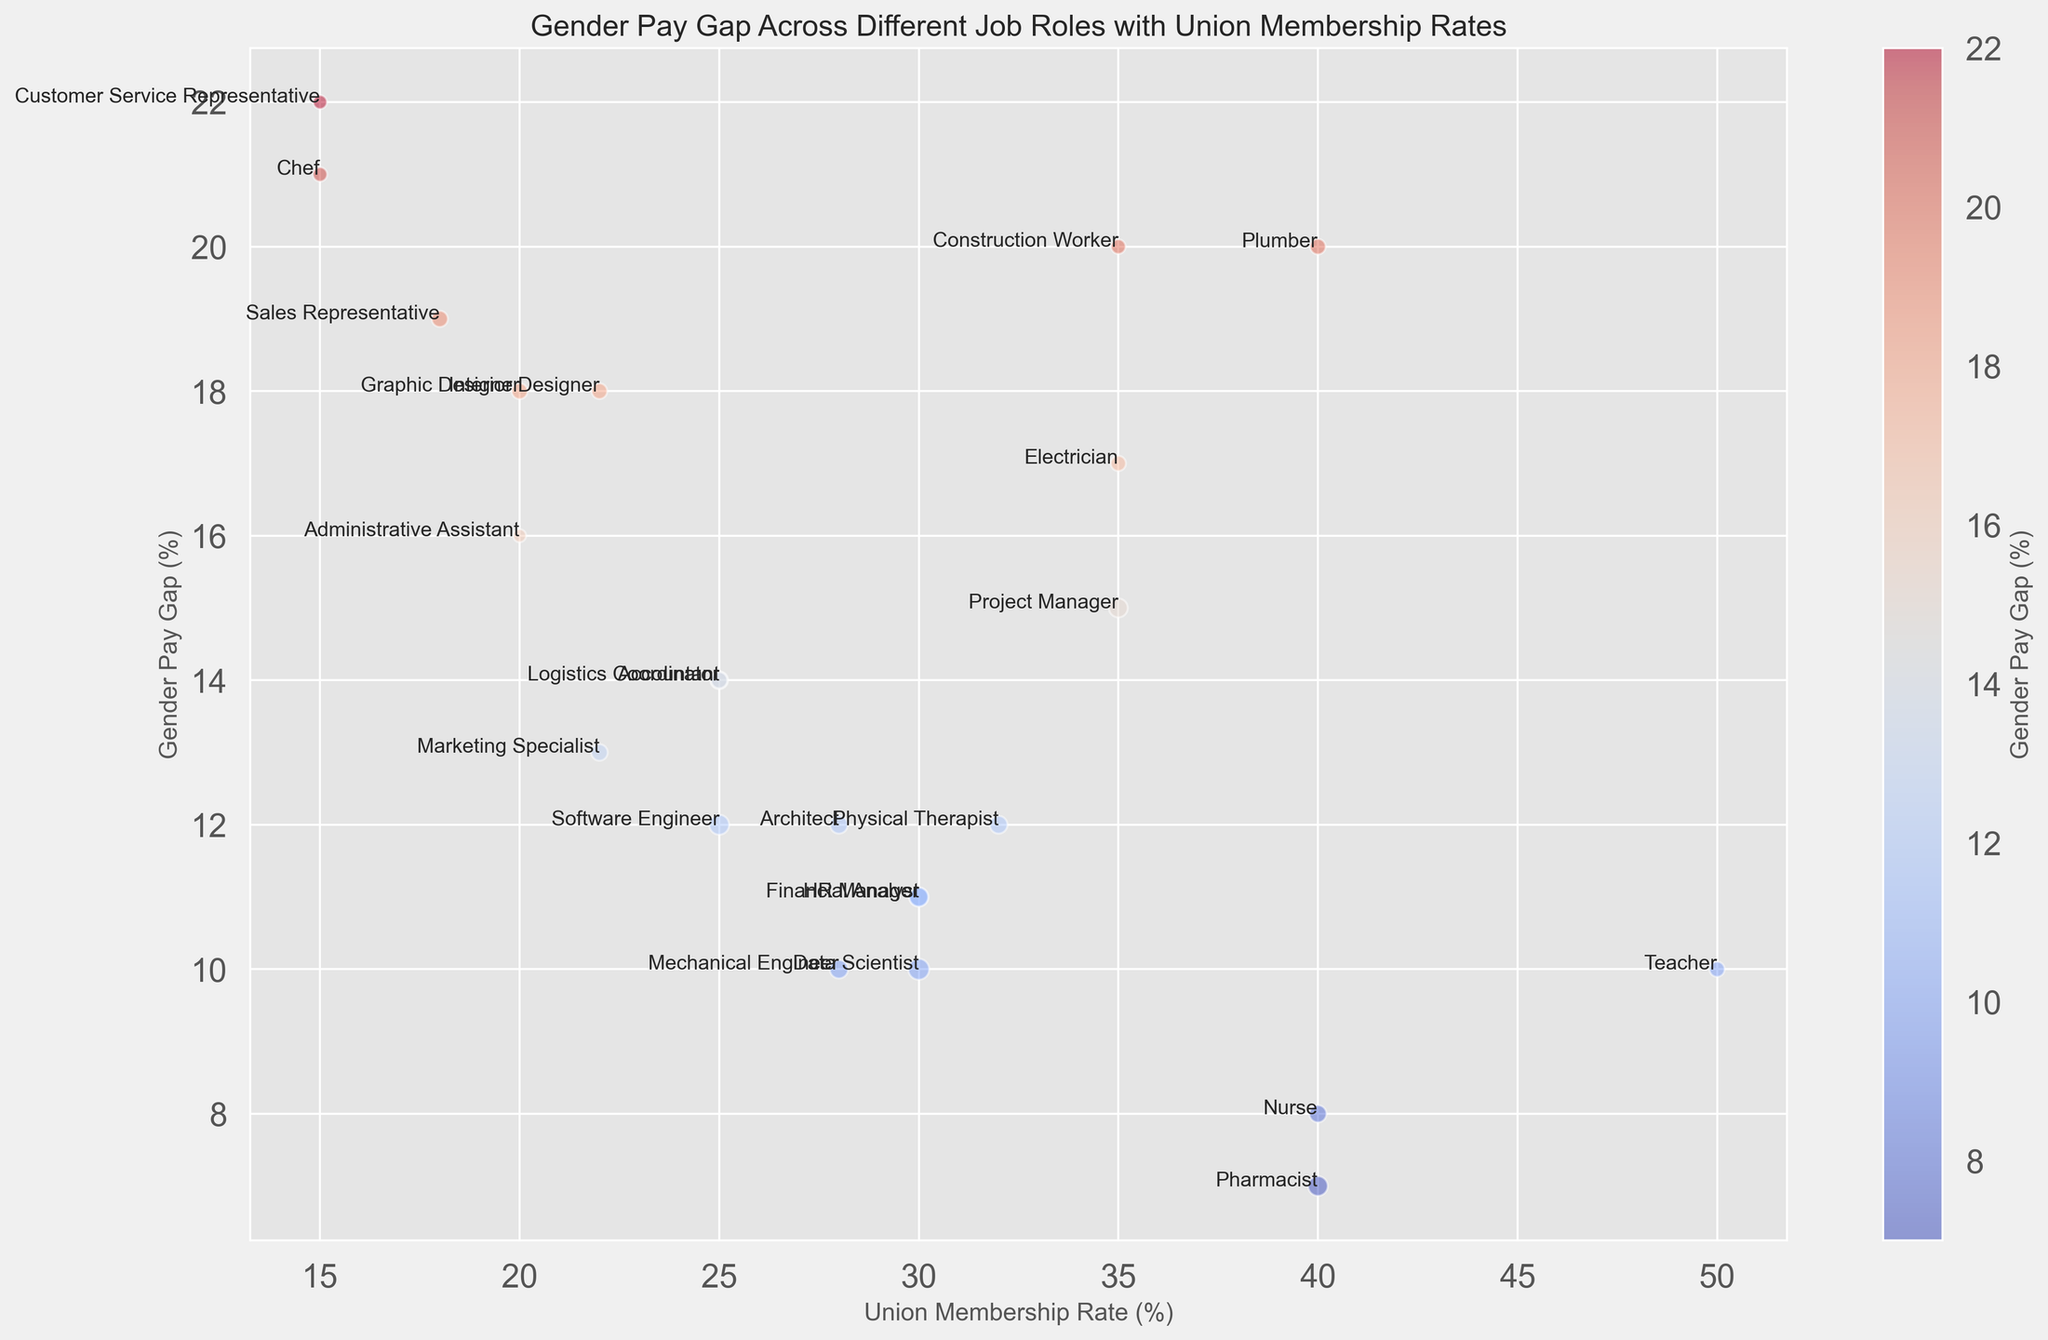Which job role has the highest gender pay gap? The bubble chart shows the gender pay gap values on the y-axis. The highest point on the y-axis will denote the job role with the highest gender pay gap.
Answer: Customer Service Representative What is the average gender pay gap for job roles with a union membership rate of 30% or higher? Identify the job roles with a union membership rate of 30% or higher. Then calculate the average of their gender pay gaps. These job roles are Data Scientist (10%), Project Manager (15%), Nurse (8%), Teacher (10%), Construction Worker (20%), Electrician (17%), Plumber (20%), Physical Therapist (12%), Pharmacist (7%). Adding their gender pay gaps: 10 + 15 + 8 + 10 + 20 + 17 + 20 + 12 + 7 = 119. The number of job roles is 9, so the average is 119 / 9.
Answer: 13.22 Which job role with a union membership rate less than 25% has the smallest gender pay gap? From the bubble chart, identify job roles where the union membership rate is less than 25%. These job roles are Software Engineer, Graphic Designer, Customer Service Representative, Administrative Assistant, Marketing Specialist, Sales Representative, Chef, Logistics Coordinator, Interior Designer. Then, compare their gender pay gaps to find the smallest one.
Answer: Software Engineer How does the gender pay gap of Data Scientist compare to that of Financial Analyst? Locate Data Scientist and Financial Analyst on the bubble chart and compare their y-axis values which represent the gender pay gaps.
Answer: The gender pay gaps for both Data Scientist and Financial Analyst are equal Among the job roles with a union membership rate of 35%, which has the largest gender pay gap from the plot? Identify the job roles with a union membership rate of 35% using union membership rates on the x-axis: Project Manager, Construction Worker, Electrician. Compare their y-axis values representing the gender pay gap.
Answer: Construction Worker What is the average salary of jobs with gender pay gap less than 15%? List out job roles with a gender pay gap less than 15%: Software Engineer, Data Scientist, Nurse, Teacher, Accountant, HR Manager, Pharmacist, Mechanical Engineer, Financial Analyst, Architect. Sum their average salaries: 95000 + 105000 + 70000 + 55000 + 75000 + 80000 + 92000 + 80000 + 90000 + 75000 = 857000. Divide the sum by the number of job roles, which is 10.
Answer: 85700 Compare the union membership rate and gender pay gap between Teacher and Nurse. Which has a higher rate and which has a higher gap? Locate Teacher and Nurse on the bubble chart. Look at their x-axis (union membership rate) and y-axis (gender pay gap) values. Teacher has a higher union membership rate (50% vs. 40%), while Nurse has a lower gender pay gap (8% vs. 10%).
Answer: Teacher has a higher union membership rate, and Teacher has a higher gender pay gap Which job role with an average salary greater than $90,000 has the smallest gender pay gap? Identify job roles with an average salary greater than $90,000: Software Engineer, Data Scientist, Pharmacist, Financial Analyst. Compare their y-axis values representing gender pay gaps to determine the smallest.
Answer: Pharmacist What is the relationship between union membership rate and gender pay gap for job roles with a bubble size representing an average salary above $80,000? From the chart, observe the union membership rates (x-axis) and gender pay gaps (y-axis) of job roles with bubble sizes indicating average salaries above $80,000. Assess if there's a trend or correlation such as an increase in one leads to an increase in the other.
Answer: Mixed relationship as there's no clear increasing or decreasing trend 